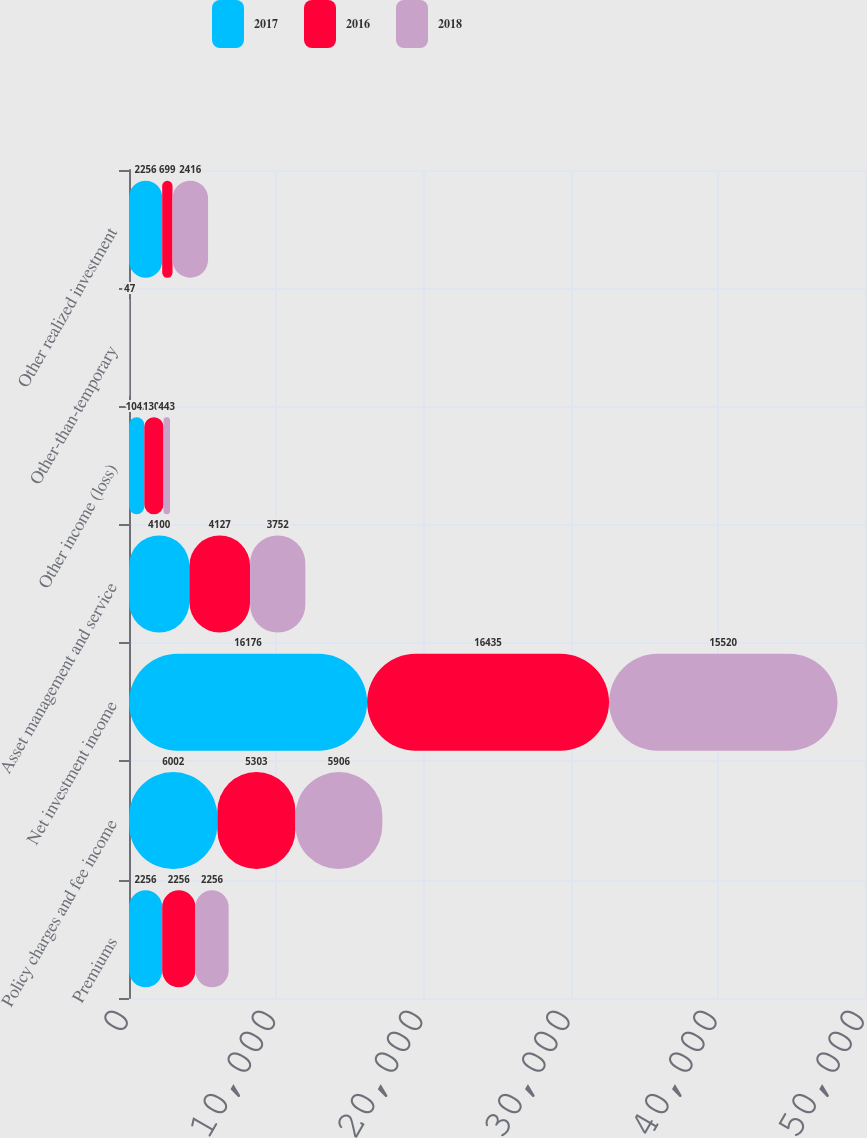Convert chart. <chart><loc_0><loc_0><loc_500><loc_500><stacked_bar_chart><ecel><fcel>Premiums<fcel>Policy charges and fee income<fcel>Net investment income<fcel>Asset management and service<fcel>Other income (loss)<fcel>Other-than-temporary<fcel>Other realized investment<nl><fcel>2017<fcel>2256<fcel>6002<fcel>16176<fcel>4100<fcel>1042<fcel>0<fcel>2256<nl><fcel>2016<fcel>2256<fcel>5303<fcel>16435<fcel>4127<fcel>1301<fcel>22<fcel>699<nl><fcel>2018<fcel>2256<fcel>5906<fcel>15520<fcel>3752<fcel>443<fcel>47<fcel>2416<nl></chart> 